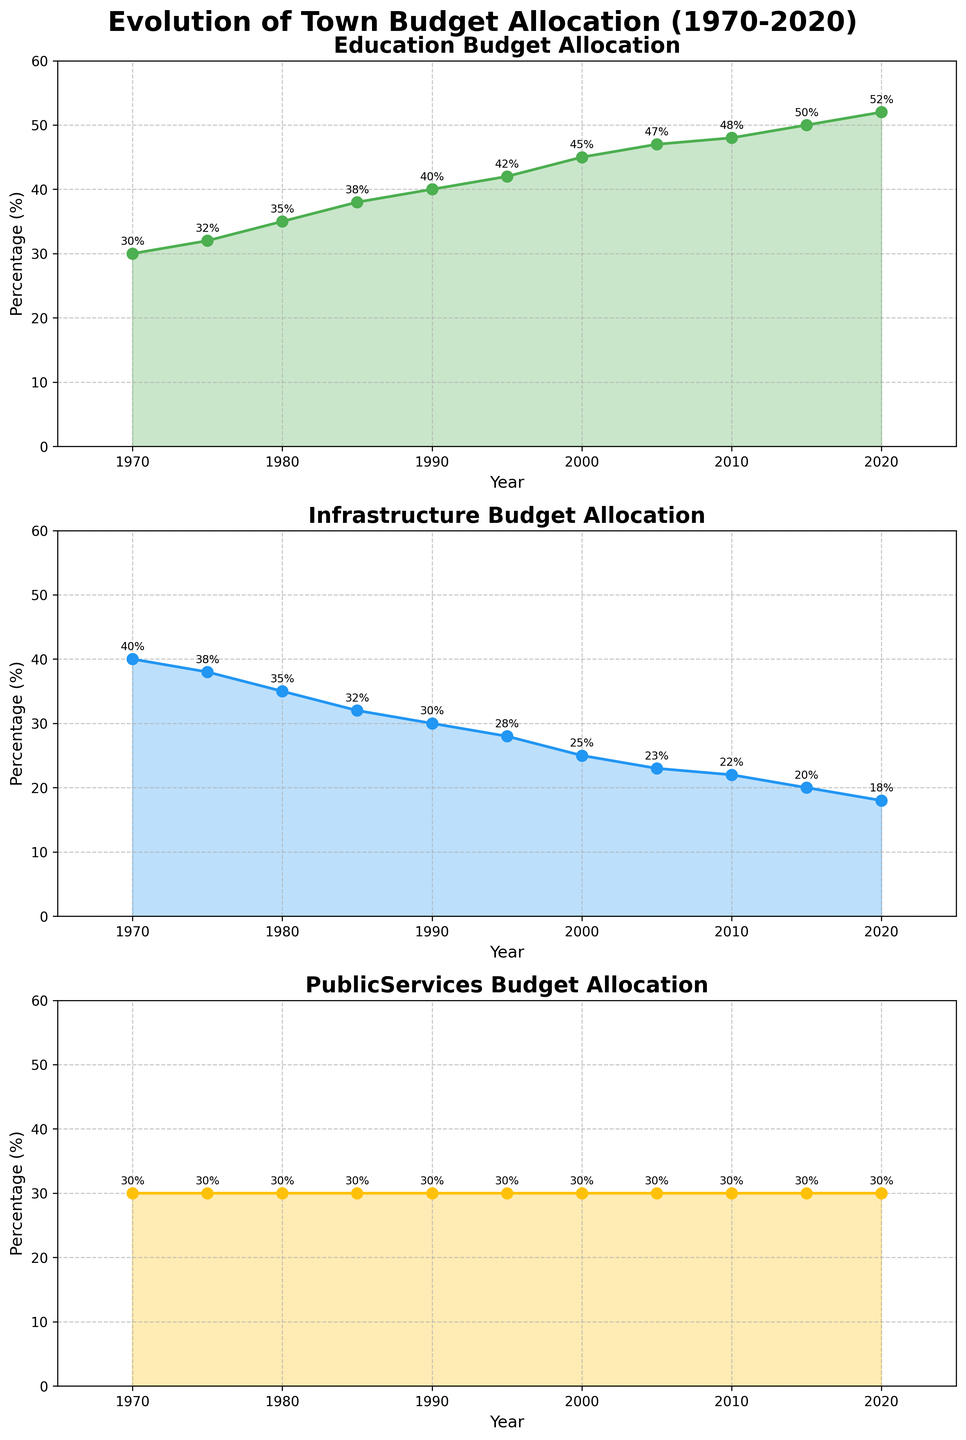what is the trend in the budget allocation for education from 1970 to 2020? The education budget allocation increases steadily from 30% in 1970 to 52% in 2020.
Answer: It increases Which budget category had the least change percentage-wise from 1970 to 2020? The public services budget allocation remained constant at 30%, compared to education and infrastructure which showed substantial variations.
Answer: Public services By how much did the infrastructure budget allocation decrease between 1970 and 2020? The infrastructure budget allocation decreased from 40% in 1970 to 18% in 2020. The decrease is calculated as 40% - 18% = 22%.
Answer: 22% Between what years did the education budget allocation exceed the infrastructure budget allocation? The education budget allocation first exceeded the infrastructure budget allocation between 1980 and 1985. From the end of that interval onward (1985 to 2020), education consistently had a higher budget allocation than infrastructure.
Answer: Between 1980 and 1985 Compare the years 1985 and 2005: Which budget category remained unchanged? The public services budget allocation remained unchanged at 30% between 1985 and 2005.
Answer: Public services By how much did the budget allocation for education increase between 2000 and 2020? The education budget allocation increased from 45% in 2000 to 52% in 2020. The difference is 52% - 45% = 7%.
Answer: 7% What visual feature makes it easy to see the trend in the education budget allocation? The consistent upward slope of the plotted line with marker points and the color fill creates a clear visual of a steady increase in the education budget allocation.
Answer: Consistent upward slope In which year did the infrastructure budget allocation reach its lowest value? By examining the trend line for the infrastructure budget, the lowest value of 18% occurred in the year 2020.
Answer: 2020 Considering the year 1990, which category had the highest budget allocation? In 1990, the education budget had the highest allocation at 40%, compared to infrastructure at 30% and public services at 30%.
Answer: Education What is the difference in percentage points between the budget allocations for education and public services in 2020? The budget allocation for education in 2020 is 52%, and for public services, it is 30%. The difference is calculated as 52% - 30% = 22%.
Answer: 22% 